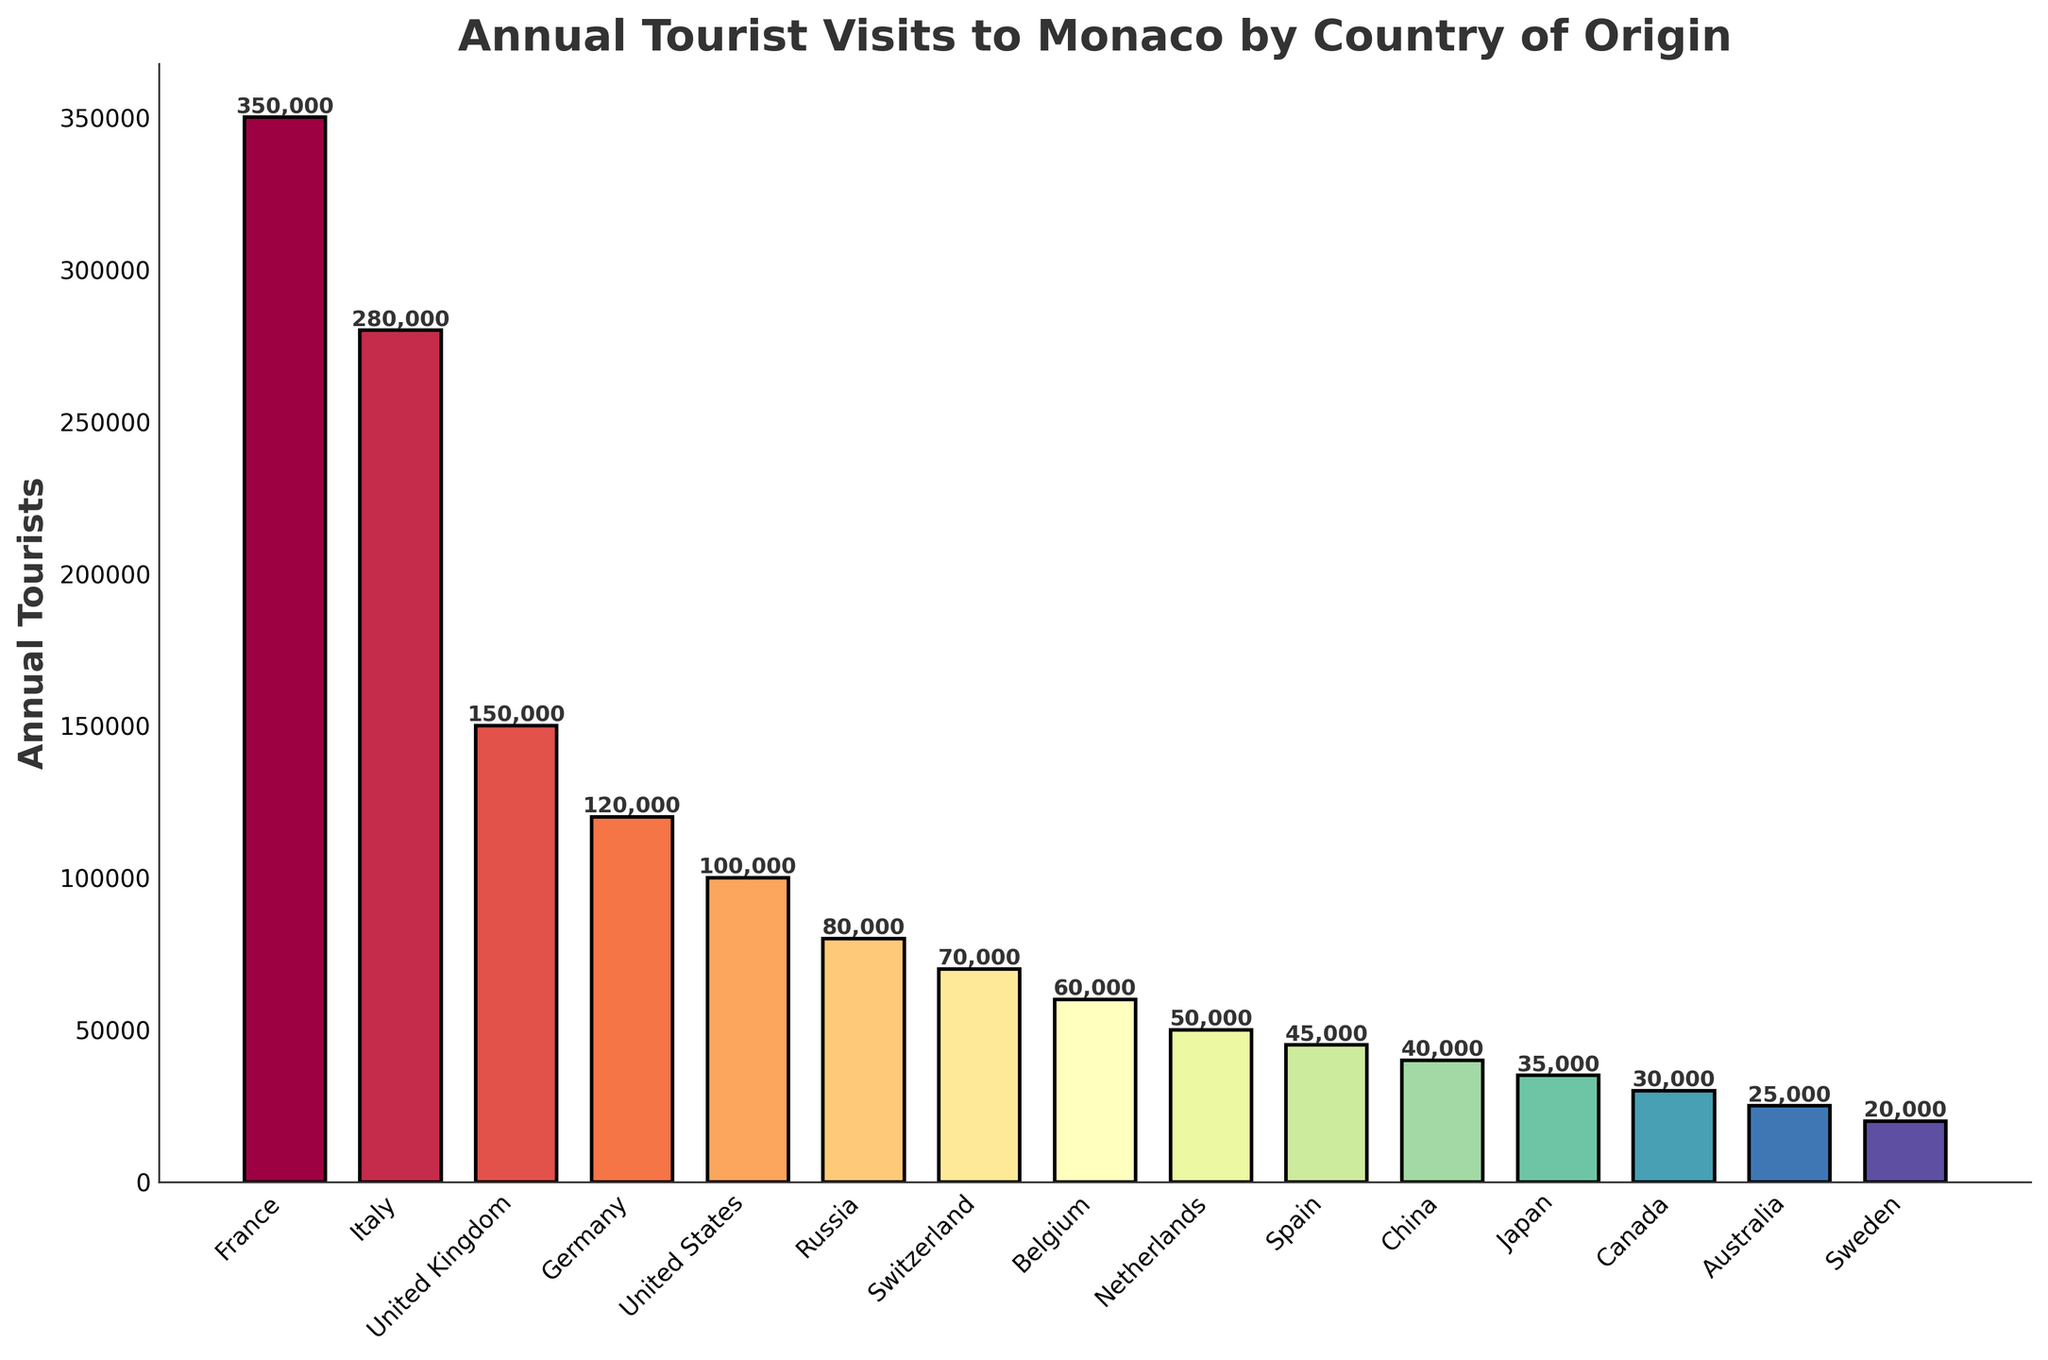What is the country with the highest number of annual tourists visiting Monaco? Look at the bar representing France; it is the tallest among all, indicating the highest number of annual tourists.
Answer: France Which country contributes more tourists to Monaco, France or Italy? Compare the heights of the bars for France and Italy. The bar for France is taller, indicating a greater number of tourists.
Answer: France By how much does the number of tourists from the United Kingdom exceed the number of tourists from Germany? Look at the bars for the United Kingdom and Germany. Subtract the number of tourists from Germany (120,000) from the number of tourists from the United Kingdom (150,000). 150,000 - 120,000 = 30,000.
Answer: 30,000 What is the total number of tourists from the top three countries (France, Italy, United Kingdom)? Add the number of tourists from these three countries. France (350,000), Italy (280,000), and United Kingdom (150,000). 350,000 + 280,000 + 150,000 = 780,000.
Answer: 780,000 How many more tourists are there from the United States compared to China? Find the bars for the United States and China. Subtract the number of tourists from China (40,000) from the number of tourists from the United States (100,000). 100,000 - 40,000 = 60,000.
Answer: 60,000 Which country contributes fewer annual tourists to Monaco, Canada or Japan? Compare the heights of the bars for Canada and Japan. The bar for Canada is shorter, indicating fewer tourists.
Answer: Canada Is the number of tourists from Switzerland greater than from Belgium? Compare the heights of the bars for Switzerland and Belgium. The bar for Switzerland is taller, indicating a greater number of tourists.
Answer: Yes Which country, Belgium or Netherlands, has fewer tourists visiting Monaco, and by how much? Compare the bars for Belgium and the Netherlands. Belgium has 60,000 tourists, and the Netherlands has 50,000. Subtract 50,000 from 60,000. 60,000 - 50,000 = 10,000.
Answer: Netherlands by 10,000 What is the combined number of tourists from Russia, Switzerland, and Belgium? Add up the tourists from these three countries. Russia (80,000), Switzerland (70,000), and Belgium (60,000). 80,000 + 70,000 + 60,000 = 210,000.
Answer: 210,000 Which country has the smallest number of tourists visiting Monaco, and what is the number? Look at the bar with the smallest height. Sweden has the smallest, with 20,000 tourists.
Answer: Sweden, 20,000 